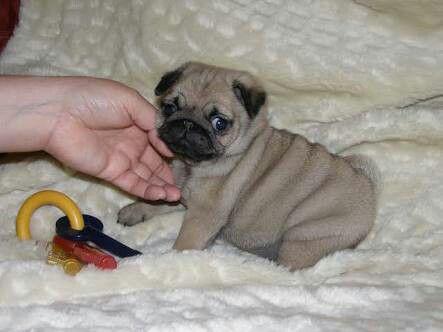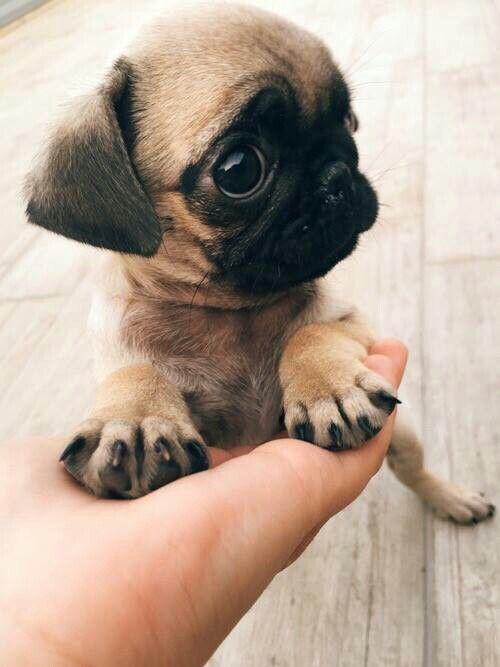The first image is the image on the left, the second image is the image on the right. Considering the images on both sides, is "There are two puppies total." valid? Answer yes or no. Yes. The first image is the image on the left, the second image is the image on the right. Analyze the images presented: Is the assertion "There are two puppies" valid? Answer yes or no. Yes. 